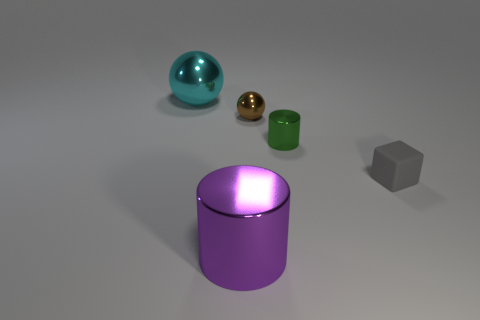Add 4 large cyan metal balls. How many objects exist? 9 Subtract all cylinders. How many objects are left? 3 Add 4 cyan balls. How many cyan balls are left? 5 Add 1 big brown balls. How many big brown balls exist? 1 Subtract 0 yellow spheres. How many objects are left? 5 Subtract all big things. Subtract all cyan metal balls. How many objects are left? 2 